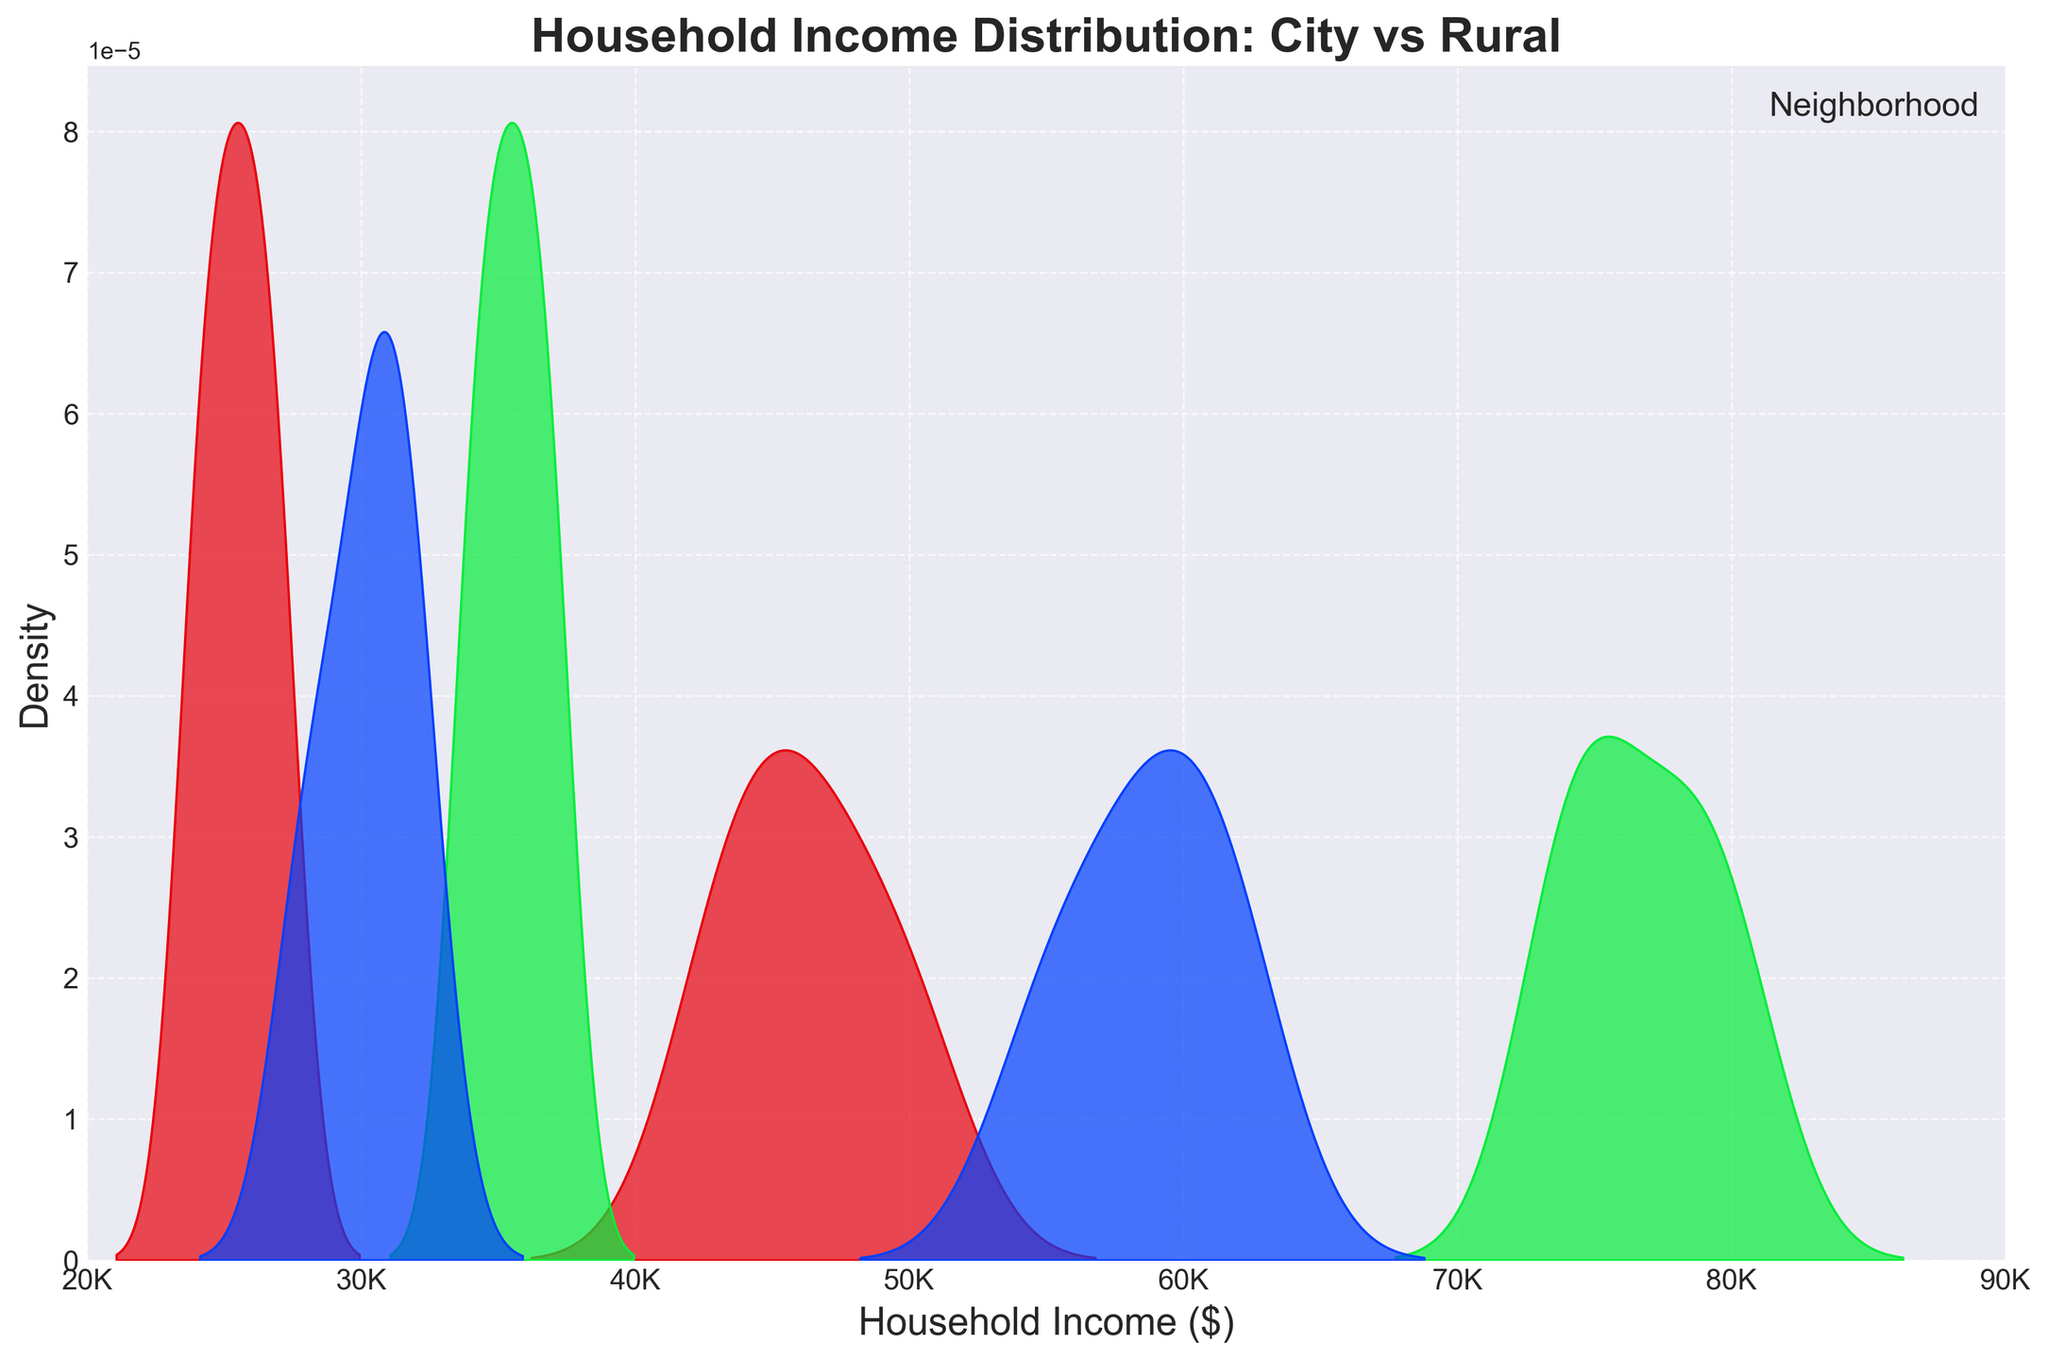What's the title of the figure? The title of the figure is prominently displayed at the top center and reads "Household Income Distribution: City vs Rural".
Answer: Household Income Distribution: City vs Rural What are the x-axis and y-axis labels? The x-axis label is "Household Income ($)" and the y-axis label is "Density". These labels are positioned below the x-axis and beside the y-axis respectively.
Answer: Household Income ($), Density Which neighborhood in the city has the highest density peak for household income? To find the neighborhood in the city with the highest density peak, look at the smooth curves and identify the peak that reaches the highest point. Broadway's curve reaches the highest peak.
Answer: Broadway What household income range is common for rural areas? To find the common household income range for rural areas, observe where the density curves for Meadowlands, Hillsdale, and Sunset Valley are thickest. Most peaks are between $20K to $40K.
Answer: $20K to $40K Between Greenwood and Eastside in the city, which neighborhood has a lower average household income? To compare the average household incomes, note that Eastside's density curve peaks at a lower income than Greenwood’s curve. Eastside averages around $45K, while Greenwood averages around $60K.
Answer: Eastside What are the household income ranges for city neighborhoods compared to rural areas? Compare the density curves. City neighborhoods (Greenwood, Broadway, Eastside) have household income ranges between $40K to $80K, while rural areas range from $20K to $40K.
Answer: City: $40K to $80K, Rural: $20K to $40K Which neighborhood has the widest spread in incomes? Look for the neighborhood whose density curve covers the broadest range along the x-axis. Broadway spreads significantly from $70K to $80K.
Answer: Broadway Is there any overlap in the household income ranges of city and rural areas? To check for overlaps, see if any density curves from cities and rural areas intersect or share income ranges. There is no substantial overlap as city ranges start around $40K and rural ends at $40K.
Answer: No Which rural neighborhood appears to have the lowest household income? Identify the neighborhood with the lowest density curve position. Sunset Valley's curve peaks around $25K, which is the lowest among rural neighborhoods.
Answer: Sunset Valley 